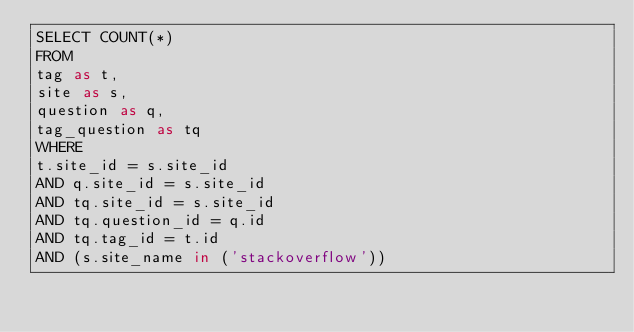Convert code to text. <code><loc_0><loc_0><loc_500><loc_500><_SQL_>SELECT COUNT(*)
FROM
tag as t,
site as s,
question as q,
tag_question as tq
WHERE
t.site_id = s.site_id
AND q.site_id = s.site_id
AND tq.site_id = s.site_id
AND tq.question_id = q.id
AND tq.tag_id = t.id
AND (s.site_name in ('stackoverflow'))</code> 